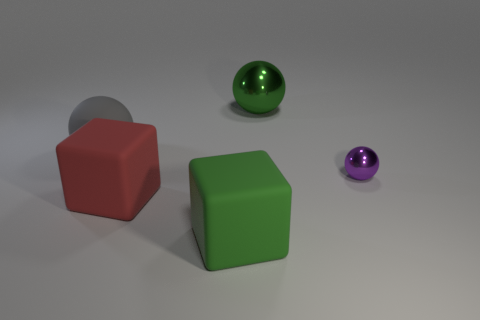What shape is the thing that is the same color as the large shiny sphere?
Ensure brevity in your answer.  Cube. Is there any other thing that has the same material as the purple sphere?
Provide a short and direct response. Yes. Is the tiny thing made of the same material as the gray object?
Your response must be concise. No. There is a rubber object on the right side of the large rubber cube that is on the left side of the big rubber block right of the large red rubber object; what is its shape?
Ensure brevity in your answer.  Cube. Are there fewer tiny metal things that are left of the red rubber object than large matte objects behind the small purple ball?
Give a very brief answer. Yes. What is the shape of the big green thing behind the thing on the right side of the large green shiny sphere?
Your answer should be compact. Sphere. Is there any other thing of the same color as the large metallic thing?
Your answer should be very brief. Yes. How many yellow things are small balls or big balls?
Ensure brevity in your answer.  0. Is the number of big green metallic balls that are in front of the green metallic object less than the number of cyan shiny objects?
Offer a very short reply. No. There is a green object that is in front of the red rubber cube; how many big blocks are behind it?
Offer a very short reply. 1. 